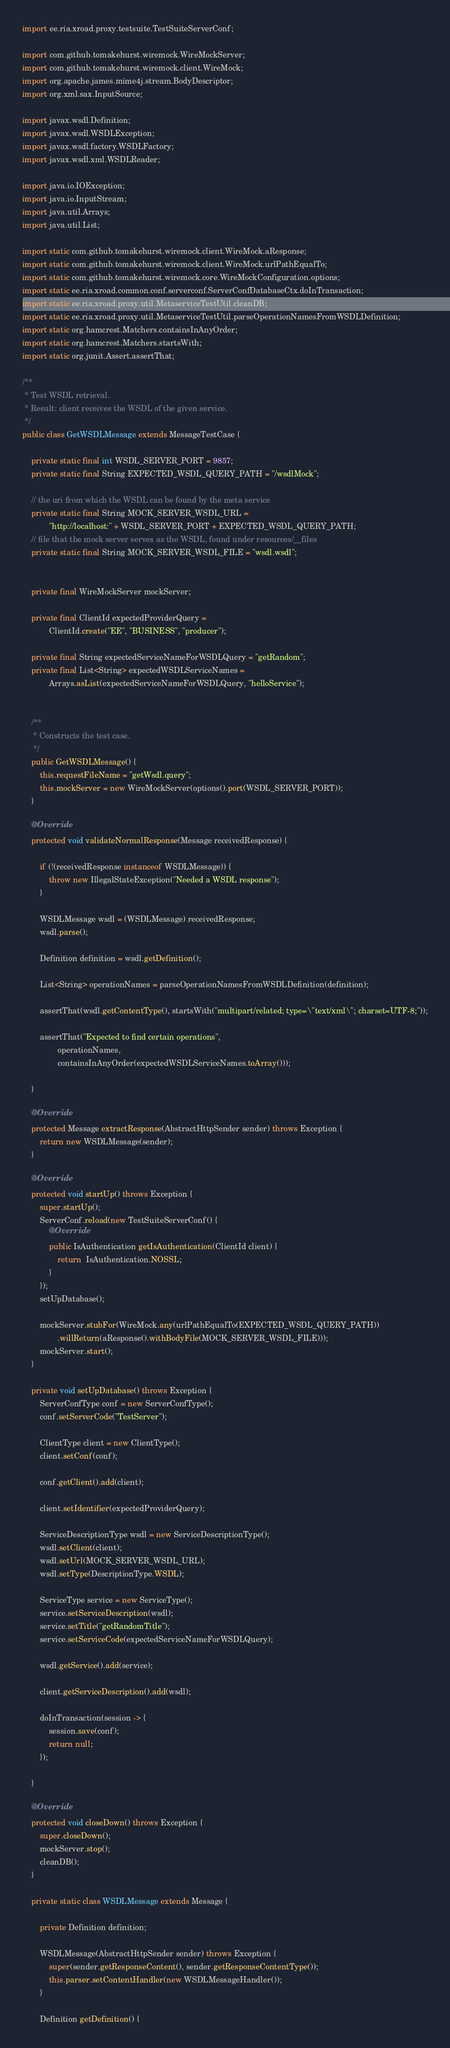<code> <loc_0><loc_0><loc_500><loc_500><_Java_>import ee.ria.xroad.proxy.testsuite.TestSuiteServerConf;

import com.github.tomakehurst.wiremock.WireMockServer;
import com.github.tomakehurst.wiremock.client.WireMock;
import org.apache.james.mime4j.stream.BodyDescriptor;
import org.xml.sax.InputSource;

import javax.wsdl.Definition;
import javax.wsdl.WSDLException;
import javax.wsdl.factory.WSDLFactory;
import javax.wsdl.xml.WSDLReader;

import java.io.IOException;
import java.io.InputStream;
import java.util.Arrays;
import java.util.List;

import static com.github.tomakehurst.wiremock.client.WireMock.aResponse;
import static com.github.tomakehurst.wiremock.client.WireMock.urlPathEqualTo;
import static com.github.tomakehurst.wiremock.core.WireMockConfiguration.options;
import static ee.ria.xroad.common.conf.serverconf.ServerConfDatabaseCtx.doInTransaction;
import static ee.ria.xroad.proxy.util.MetaserviceTestUtil.cleanDB;
import static ee.ria.xroad.proxy.util.MetaserviceTestUtil.parseOperationNamesFromWSDLDefinition;
import static org.hamcrest.Matchers.containsInAnyOrder;
import static org.hamcrest.Matchers.startsWith;
import static org.junit.Assert.assertThat;

/**
 * Test WSDL retrieval.
 * Result: client receives the WSDL of the given service.
 */
public class GetWSDLMessage extends MessageTestCase {

    private static final int WSDL_SERVER_PORT = 9857;
    private static final String EXPECTED_WSDL_QUERY_PATH = "/wsdlMock";

    // the uri from which the WSDL can be found by the meta service
    private static final String MOCK_SERVER_WSDL_URL =
            "http://localhost:" + WSDL_SERVER_PORT + EXPECTED_WSDL_QUERY_PATH;
    // file that the mock server serves as the WSDL, found under resources/__files
    private static final String MOCK_SERVER_WSDL_FILE = "wsdl.wsdl";


    private final WireMockServer mockServer;

    private final ClientId expectedProviderQuery =
            ClientId.create("EE", "BUSINESS", "producer");

    private final String expectedServiceNameForWSDLQuery = "getRandom";
    private final List<String> expectedWSDLServiceNames =
            Arrays.asList(expectedServiceNameForWSDLQuery, "helloService");


    /**
     * Constructs the test case.
     */
    public GetWSDLMessage() {
        this.requestFileName = "getWsdl.query";
        this.mockServer = new WireMockServer(options().port(WSDL_SERVER_PORT));
    }

    @Override
    protected void validateNormalResponse(Message receivedResponse) {

        if (!(receivedResponse instanceof WSDLMessage)) {
            throw new IllegalStateException("Needed a WSDL response");
        }

        WSDLMessage wsdl = (WSDLMessage) receivedResponse;
        wsdl.parse();

        Definition definition = wsdl.getDefinition();

        List<String> operationNames = parseOperationNamesFromWSDLDefinition(definition);

        assertThat(wsdl.getContentType(), startsWith("multipart/related; type=\"text/xml\"; charset=UTF-8;"));

        assertThat("Expected to find certain operations",
                operationNames,
                containsInAnyOrder(expectedWSDLServiceNames.toArray()));

    }

    @Override
    protected Message extractResponse(AbstractHttpSender sender) throws Exception {
        return new WSDLMessage(sender);
    }

    @Override
    protected void startUp() throws Exception {
        super.startUp();
        ServerConf.reload(new TestSuiteServerConf() {
            @Override
            public IsAuthentication getIsAuthentication(ClientId client) {
                return  IsAuthentication.NOSSL;
            }
        });
        setUpDatabase();

        mockServer.stubFor(WireMock.any(urlPathEqualTo(EXPECTED_WSDL_QUERY_PATH))
                .willReturn(aResponse().withBodyFile(MOCK_SERVER_WSDL_FILE)));
        mockServer.start();
    }

    private void setUpDatabase() throws Exception {
        ServerConfType conf = new ServerConfType();
        conf.setServerCode("TestServer");

        ClientType client = new ClientType();
        client.setConf(conf);

        conf.getClient().add(client);

        client.setIdentifier(expectedProviderQuery);

        ServiceDescriptionType wsdl = new ServiceDescriptionType();
        wsdl.setClient(client);
        wsdl.setUrl(MOCK_SERVER_WSDL_URL);
        wsdl.setType(DescriptionType.WSDL);

        ServiceType service = new ServiceType();
        service.setServiceDescription(wsdl);
        service.setTitle("getRandomTitle");
        service.setServiceCode(expectedServiceNameForWSDLQuery);

        wsdl.getService().add(service);

        client.getServiceDescription().add(wsdl);

        doInTransaction(session -> {
            session.save(conf);
            return null;
        });

    }

    @Override
    protected void closeDown() throws Exception {
        super.closeDown();
        mockServer.stop();
        cleanDB();
    }

    private static class WSDLMessage extends Message {

        private Definition definition;

        WSDLMessage(AbstractHttpSender sender) throws Exception {
            super(sender.getResponseContent(), sender.getResponseContentType());
            this.parser.setContentHandler(new WSDLMessageHandler());
        }

        Definition getDefinition() {</code> 